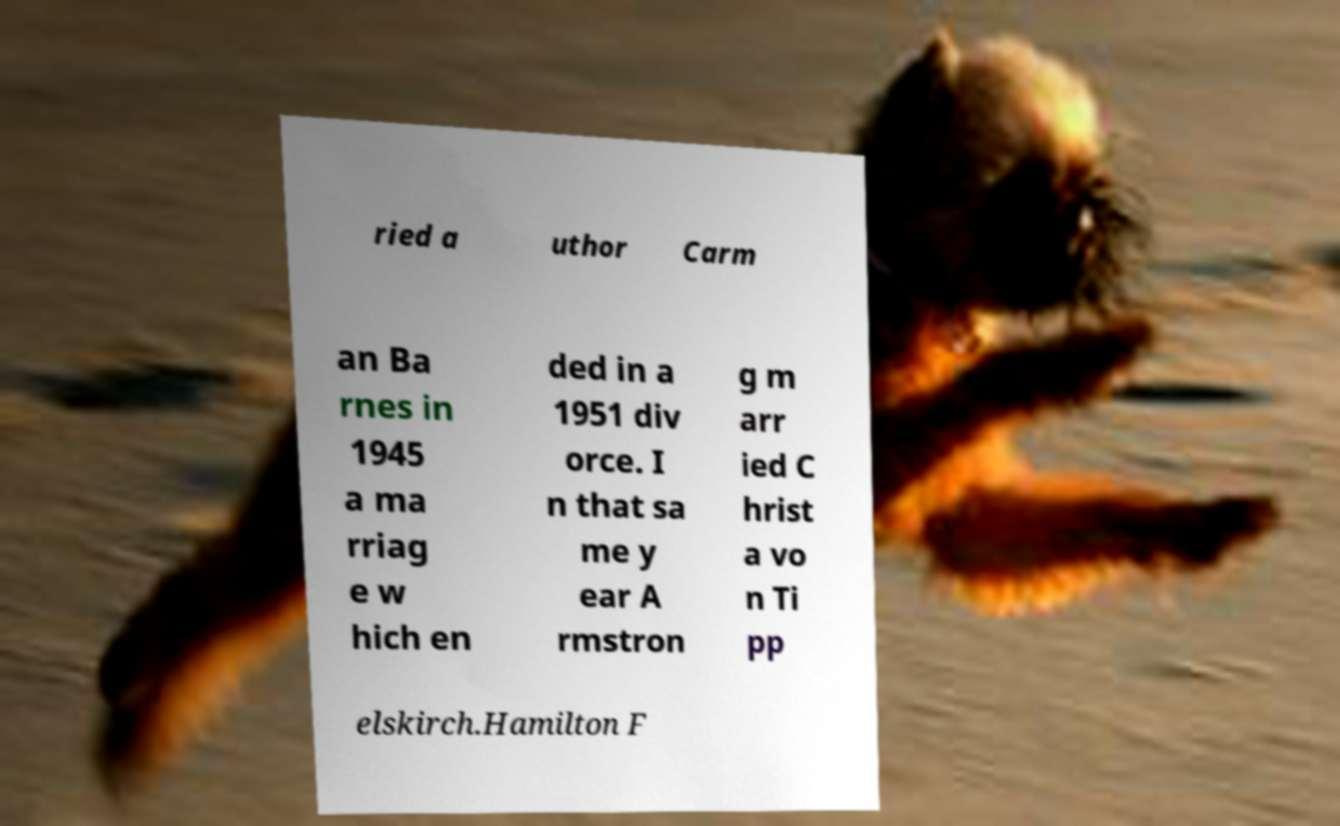What messages or text are displayed in this image? I need them in a readable, typed format. ried a uthor Carm an Ba rnes in 1945 a ma rriag e w hich en ded in a 1951 div orce. I n that sa me y ear A rmstron g m arr ied C hrist a vo n Ti pp elskirch.Hamilton F 